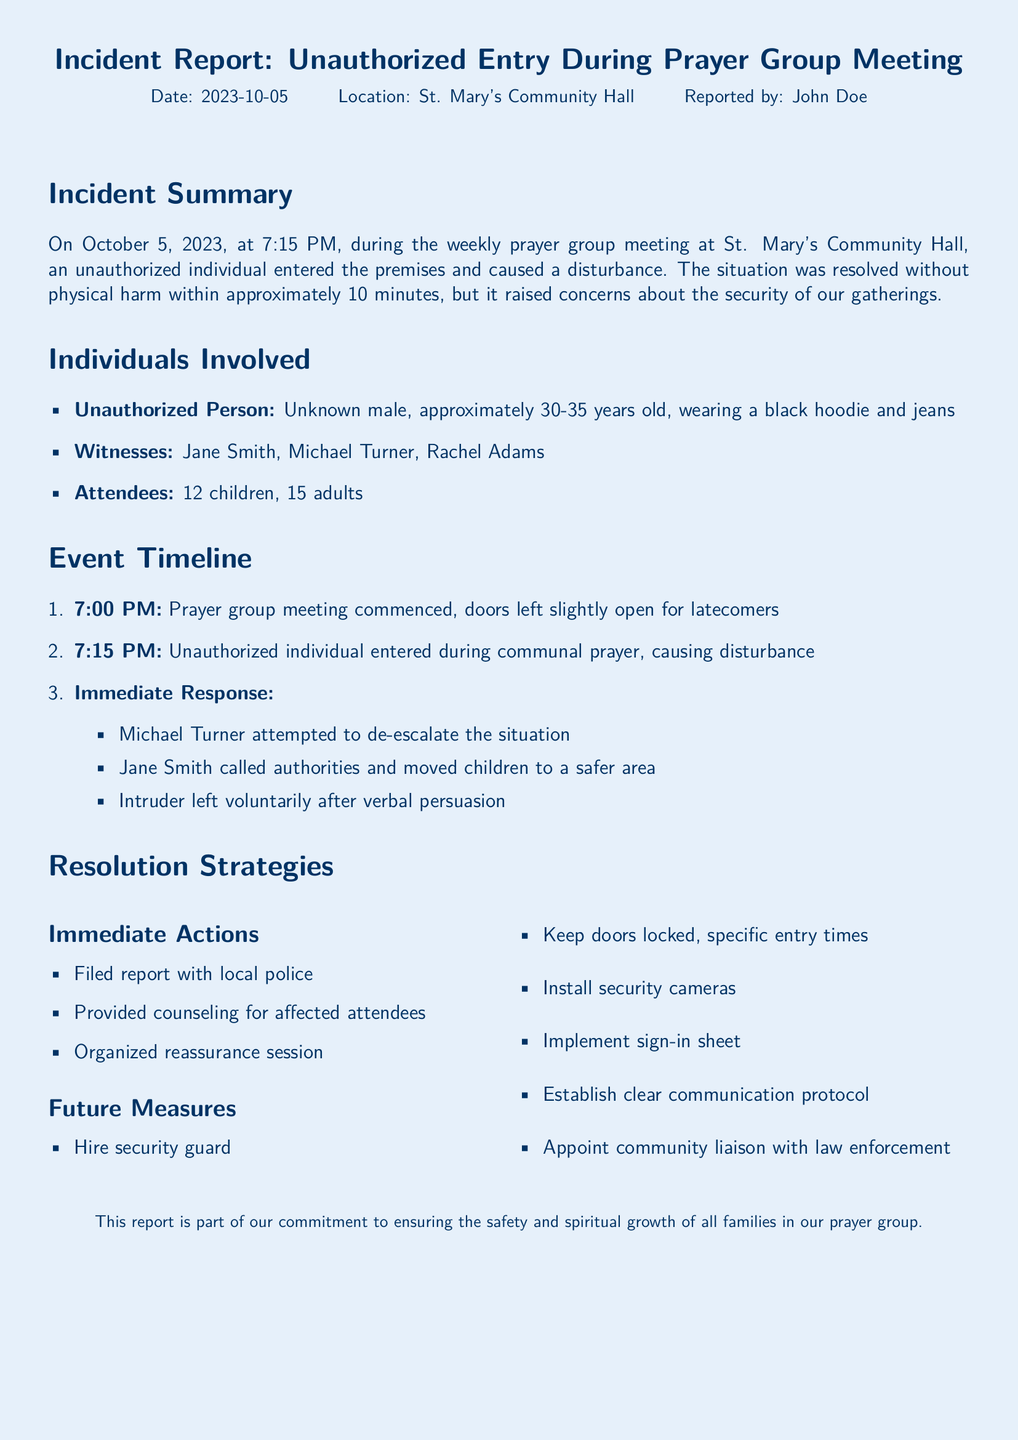what was the date of the incident? The date of the incident is specified in the report header, which is October 5, 2023.
Answer: October 5, 2023 who reported the incident? The report mentions that John Doe is the person who reported the incident.
Answer: John Doe how many adults were attending the meeting? The document states that there were 15 adults present during the prayer group meeting.
Answer: 15 what immediately happened after the unauthorized entry? The document describes a sequence of immediate responses, including efforts to de-escalate the situation and moving children to safety.
Answer: Michael Turner attempted to de-escalate the situation how long did it take to resolve the situation? The report indicates that the disturbance was resolved in approximately 10 minutes.
Answer: 10 minutes what future measure is recommended to enhance security? The report lists several future measures, including hiring a security guard to enhance security during meetings.
Answer: Hire security guard what type of document is this? The nature of the content described and organized makes it an incident report.
Answer: Incident report how many children were present during the meeting? The report specifies that there were 12 children in attendance at the prayer group meeting.
Answer: 12 who initiated the call to authorities? The document states that Jane Smith was the one who called the authorities during the incident.
Answer: Jane Smith 